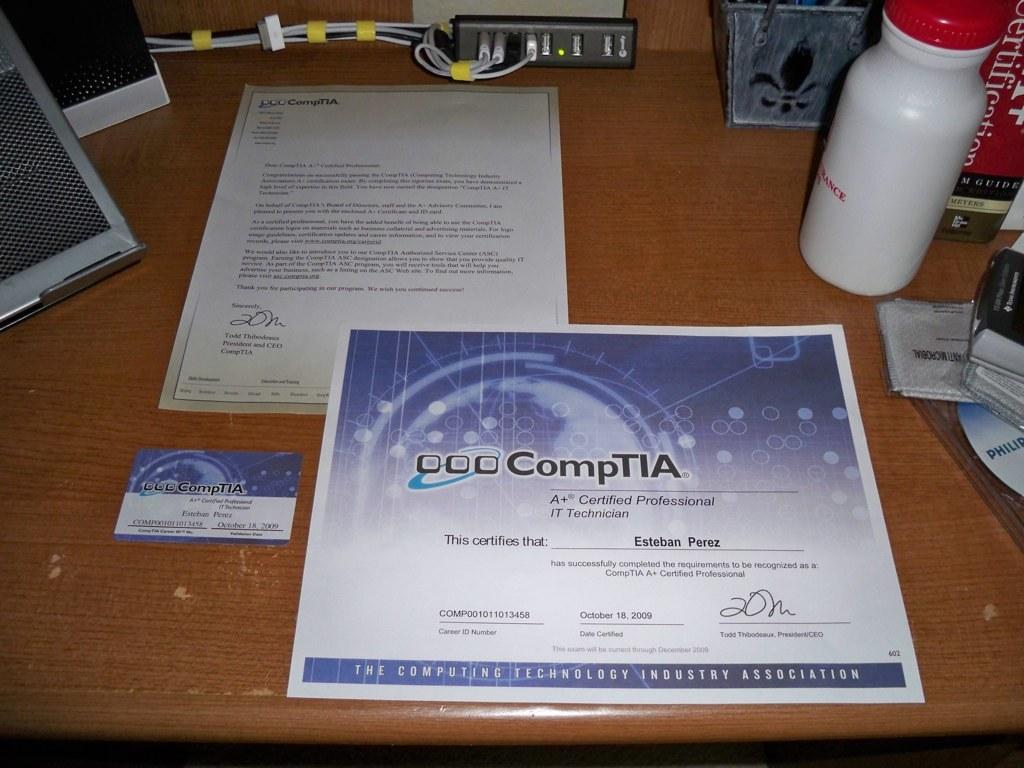Who issued this certificate?
Provide a short and direct response. Comptia. 